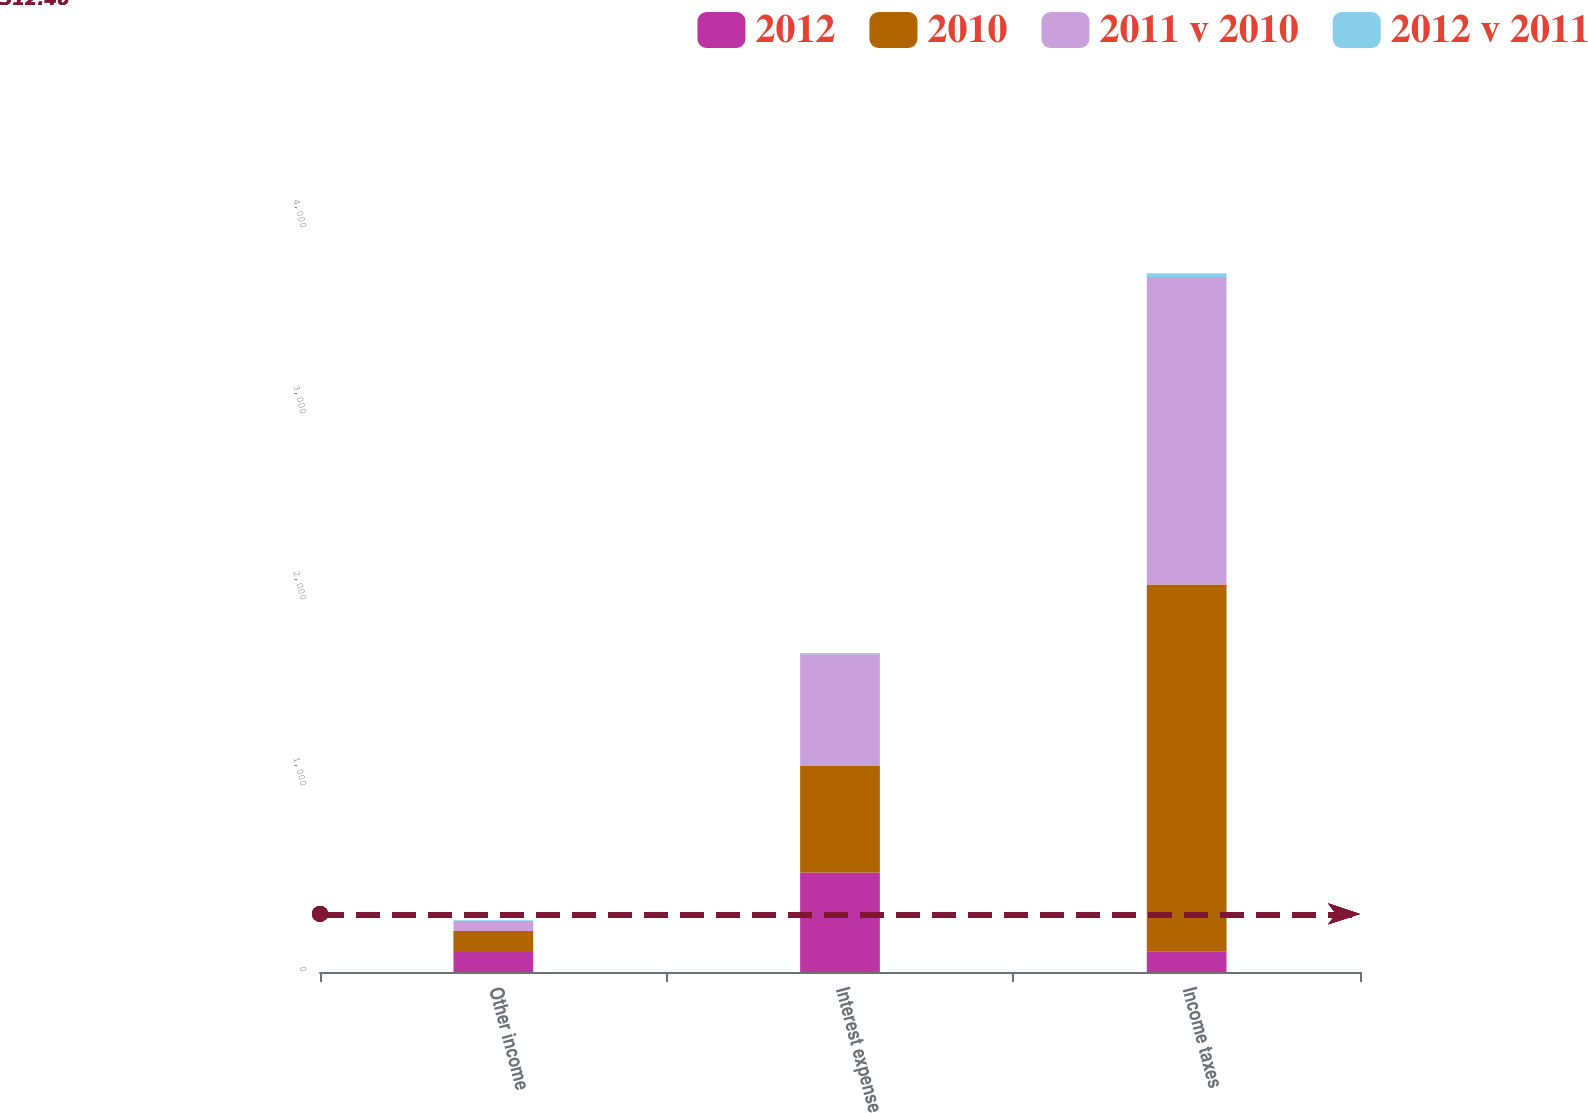<chart> <loc_0><loc_0><loc_500><loc_500><stacked_bar_chart><ecel><fcel>Other income<fcel>Interest expense<fcel>Income taxes<nl><fcel>2012<fcel>108<fcel>535<fcel>112<nl><fcel>2010<fcel>112<fcel>572<fcel>1972<nl><fcel>2011 v 2010<fcel>54<fcel>602<fcel>1653<nl><fcel>2012 v 2011<fcel>4<fcel>6<fcel>20<nl></chart> 